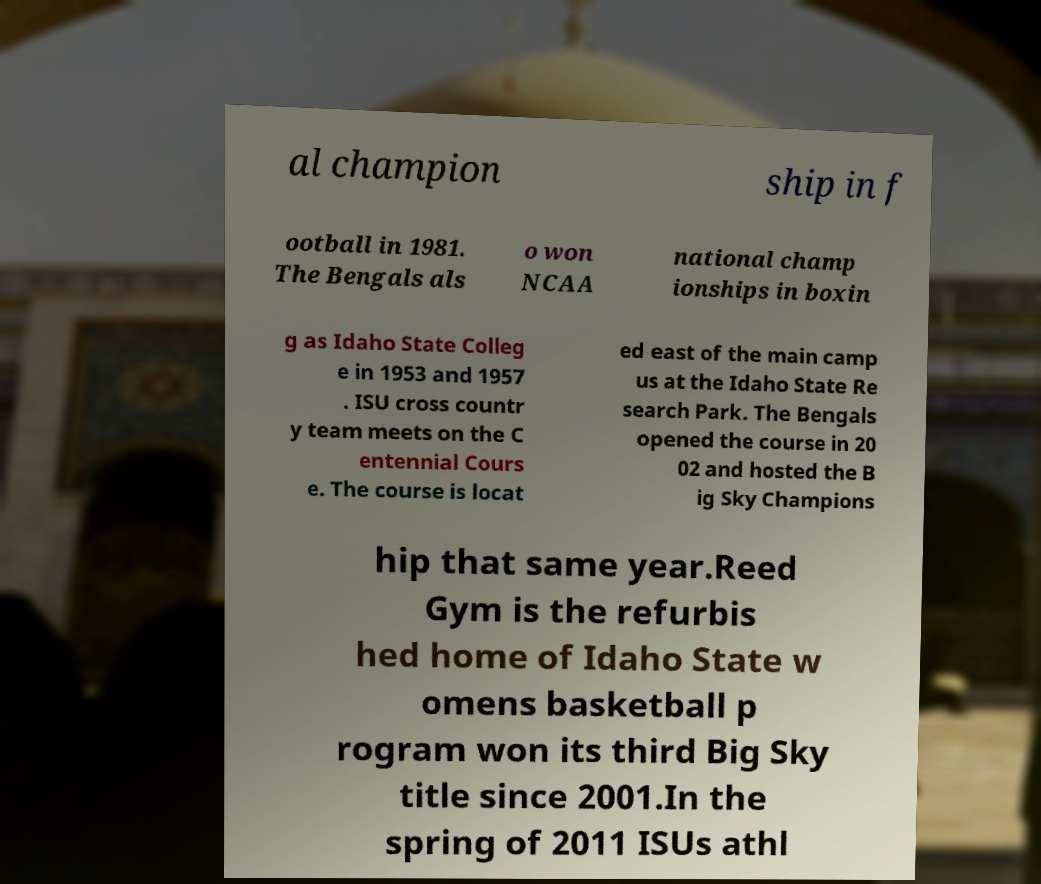I need the written content from this picture converted into text. Can you do that? al champion ship in f ootball in 1981. The Bengals als o won NCAA national champ ionships in boxin g as Idaho State Colleg e in 1953 and 1957 . ISU cross countr y team meets on the C entennial Cours e. The course is locat ed east of the main camp us at the Idaho State Re search Park. The Bengals opened the course in 20 02 and hosted the B ig Sky Champions hip that same year.Reed Gym is the refurbis hed home of Idaho State w omens basketball p rogram won its third Big Sky title since 2001.In the spring of 2011 ISUs athl 